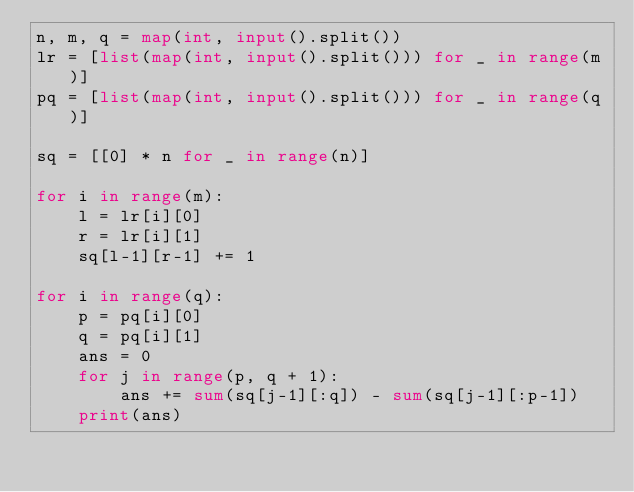<code> <loc_0><loc_0><loc_500><loc_500><_Python_>n, m, q = map(int, input().split())
lr = [list(map(int, input().split())) for _ in range(m)]
pq = [list(map(int, input().split())) for _ in range(q)]

sq = [[0] * n for _ in range(n)]

for i in range(m):
    l = lr[i][0]
    r = lr[i][1]
    sq[l-1][r-1] += 1

for i in range(q):
    p = pq[i][0]
    q = pq[i][1]
    ans = 0
    for j in range(p, q + 1):
        ans += sum(sq[j-1][:q]) - sum(sq[j-1][:p-1])
    print(ans)

</code> 